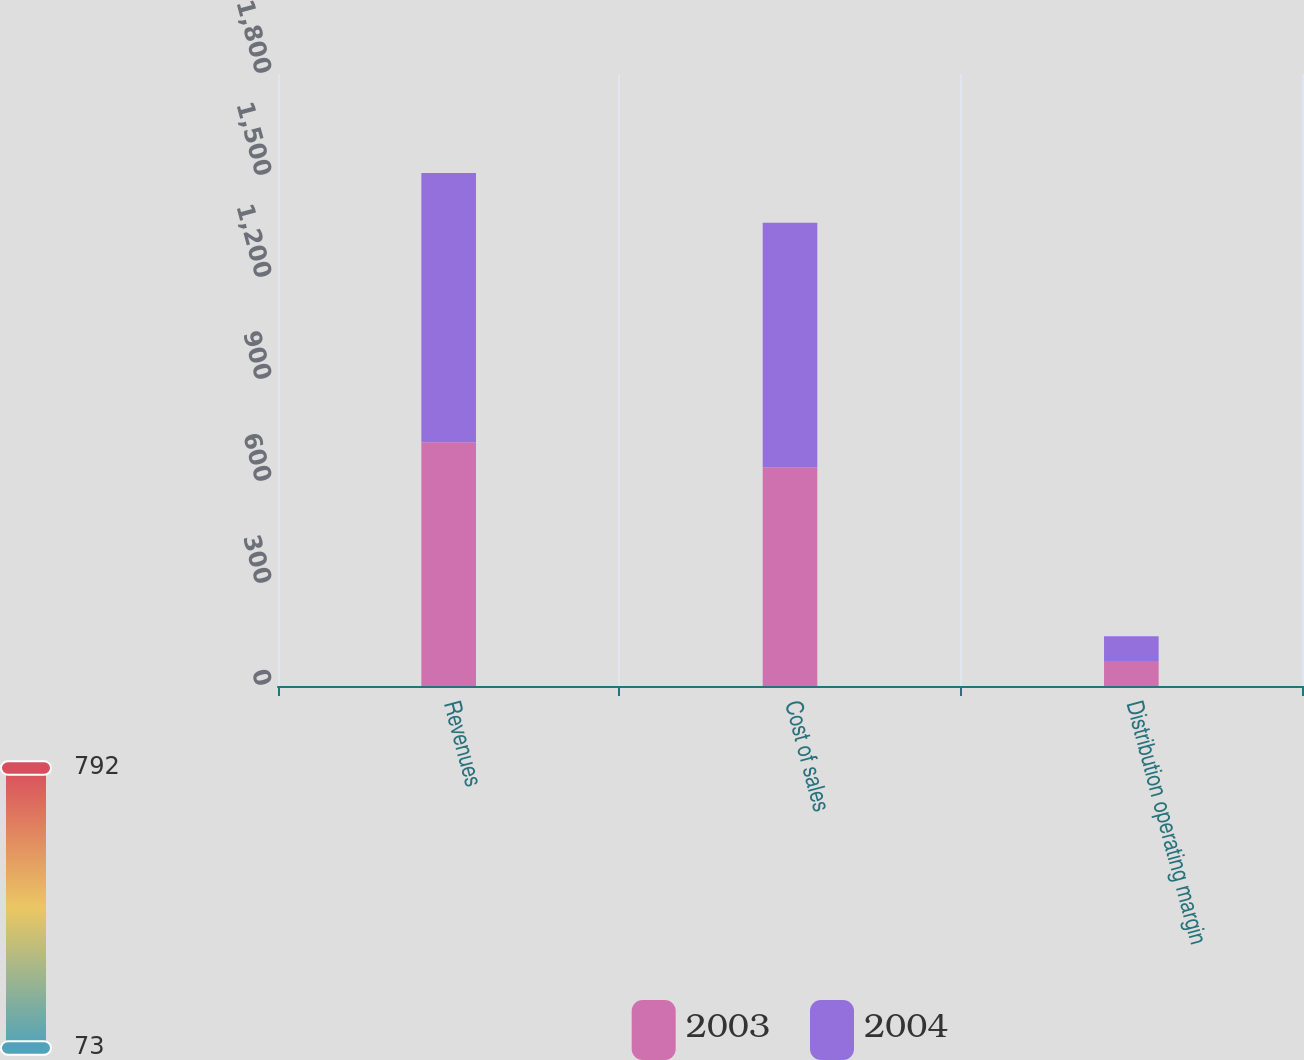Convert chart. <chart><loc_0><loc_0><loc_500><loc_500><stacked_bar_chart><ecel><fcel>Revenues<fcel>Cost of sales<fcel>Distribution operating margin<nl><fcel>2003<fcel>717.1<fcel>643.6<fcel>73.4<nl><fcel>2004<fcel>792<fcel>718.9<fcel>73.1<nl></chart> 